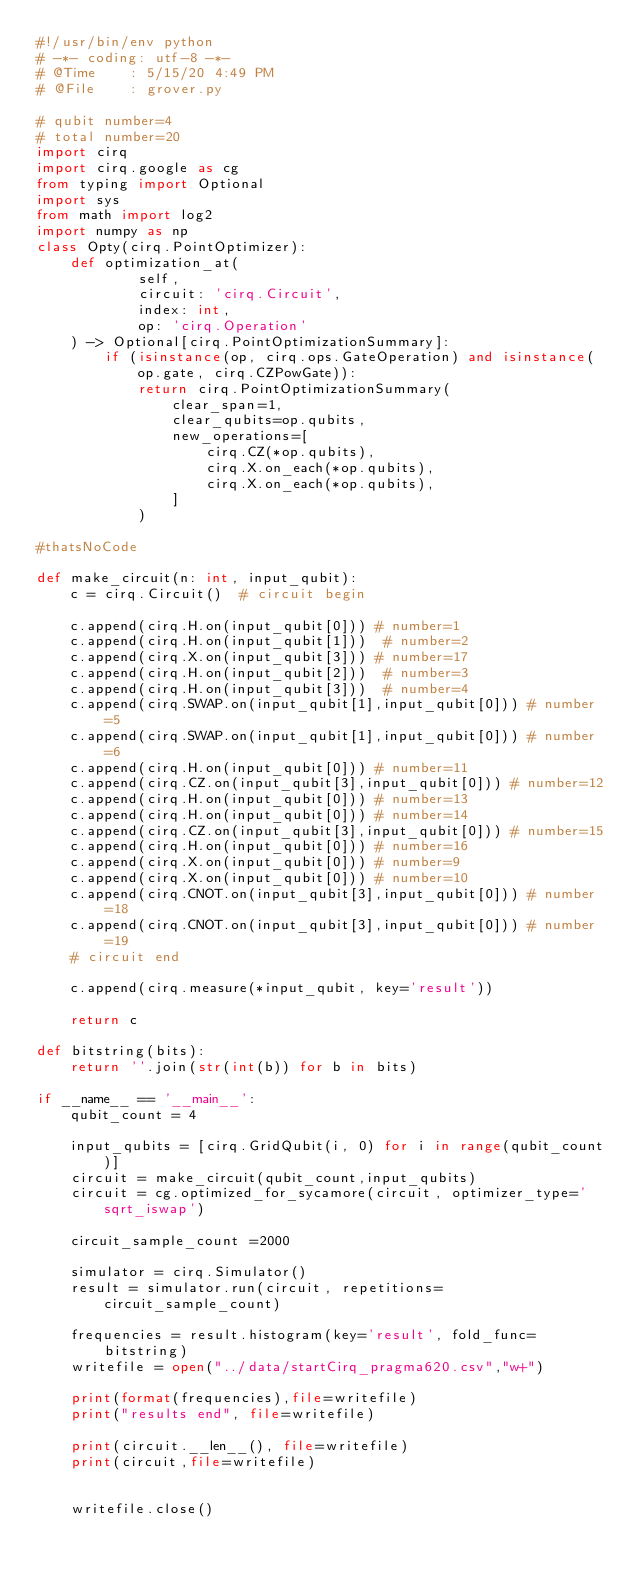Convert code to text. <code><loc_0><loc_0><loc_500><loc_500><_Python_>#!/usr/bin/env python
# -*- coding: utf-8 -*-
# @Time    : 5/15/20 4:49 PM
# @File    : grover.py

# qubit number=4
# total number=20
import cirq
import cirq.google as cg
from typing import Optional
import sys
from math import log2
import numpy as np
class Opty(cirq.PointOptimizer):
    def optimization_at(
            self,
            circuit: 'cirq.Circuit',
            index: int,
            op: 'cirq.Operation'
    ) -> Optional[cirq.PointOptimizationSummary]:
        if (isinstance(op, cirq.ops.GateOperation) and isinstance(op.gate, cirq.CZPowGate)):
            return cirq.PointOptimizationSummary(
                clear_span=1,
                clear_qubits=op.qubits, 
                new_operations=[
                    cirq.CZ(*op.qubits),
                    cirq.X.on_each(*op.qubits),
                    cirq.X.on_each(*op.qubits),
                ]
            )

#thatsNoCode

def make_circuit(n: int, input_qubit):
    c = cirq.Circuit()  # circuit begin

    c.append(cirq.H.on(input_qubit[0])) # number=1
    c.append(cirq.H.on(input_qubit[1]))  # number=2
    c.append(cirq.X.on(input_qubit[3])) # number=17
    c.append(cirq.H.on(input_qubit[2]))  # number=3
    c.append(cirq.H.on(input_qubit[3]))  # number=4
    c.append(cirq.SWAP.on(input_qubit[1],input_qubit[0])) # number=5
    c.append(cirq.SWAP.on(input_qubit[1],input_qubit[0])) # number=6
    c.append(cirq.H.on(input_qubit[0])) # number=11
    c.append(cirq.CZ.on(input_qubit[3],input_qubit[0])) # number=12
    c.append(cirq.H.on(input_qubit[0])) # number=13
    c.append(cirq.H.on(input_qubit[0])) # number=14
    c.append(cirq.CZ.on(input_qubit[3],input_qubit[0])) # number=15
    c.append(cirq.H.on(input_qubit[0])) # number=16
    c.append(cirq.X.on(input_qubit[0])) # number=9
    c.append(cirq.X.on(input_qubit[0])) # number=10
    c.append(cirq.CNOT.on(input_qubit[3],input_qubit[0])) # number=18
    c.append(cirq.CNOT.on(input_qubit[3],input_qubit[0])) # number=19
    # circuit end

    c.append(cirq.measure(*input_qubit, key='result'))

    return c

def bitstring(bits):
    return ''.join(str(int(b)) for b in bits)

if __name__ == '__main__':
    qubit_count = 4

    input_qubits = [cirq.GridQubit(i, 0) for i in range(qubit_count)]
    circuit = make_circuit(qubit_count,input_qubits)
    circuit = cg.optimized_for_sycamore(circuit, optimizer_type='sqrt_iswap')

    circuit_sample_count =2000

    simulator = cirq.Simulator()
    result = simulator.run(circuit, repetitions=circuit_sample_count)

    frequencies = result.histogram(key='result', fold_func=bitstring)
    writefile = open("../data/startCirq_pragma620.csv","w+")

    print(format(frequencies),file=writefile)
    print("results end", file=writefile)

    print(circuit.__len__(), file=writefile)
    print(circuit,file=writefile)


    writefile.close()</code> 